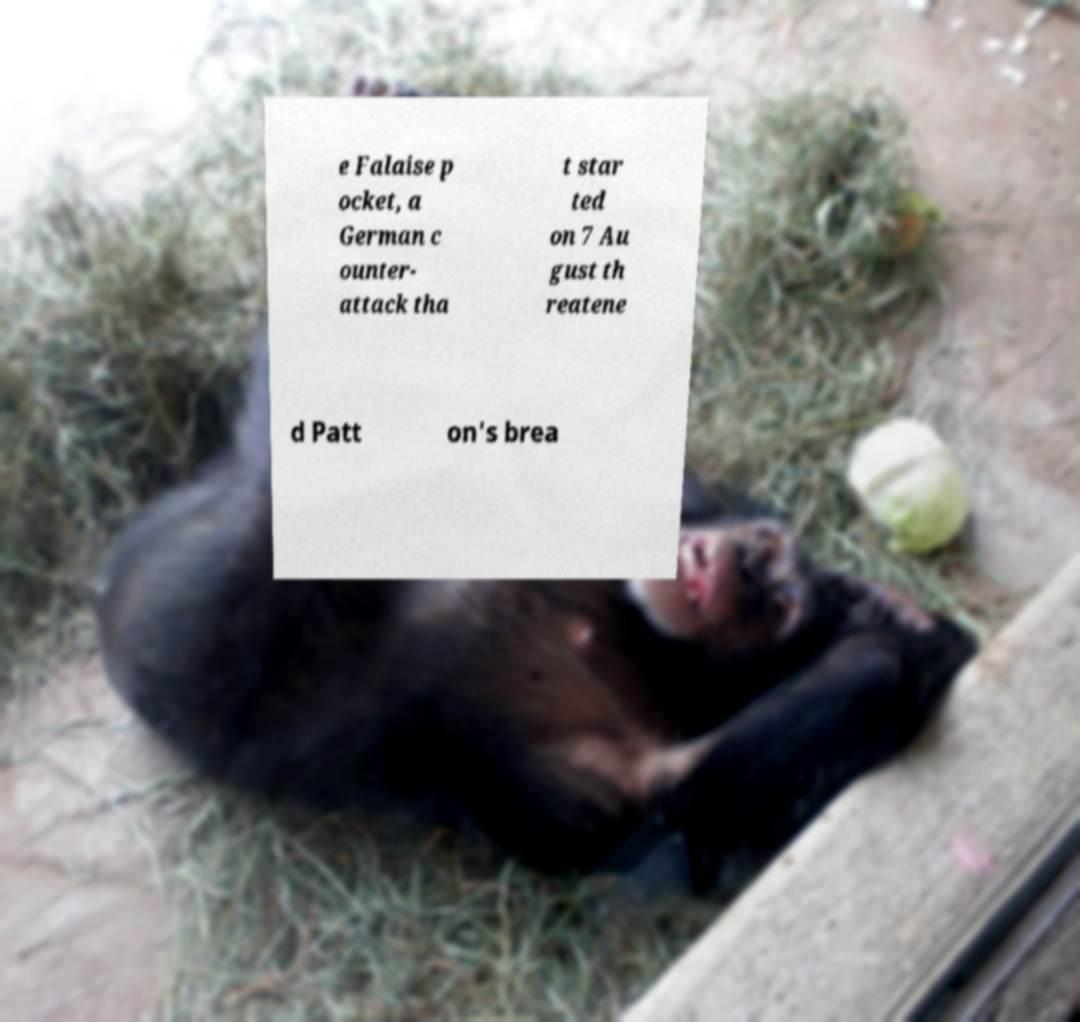Please identify and transcribe the text found in this image. e Falaise p ocket, a German c ounter- attack tha t star ted on 7 Au gust th reatene d Patt on's brea 